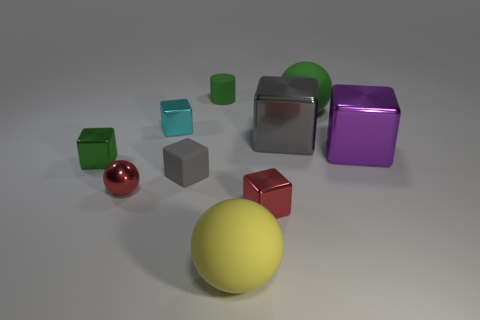What material is the object that is the same color as the shiny sphere?
Offer a terse response. Metal. There is a gray object that is the same material as the big purple block; what shape is it?
Your answer should be compact. Cube. There is a green cube; what number of red cubes are behind it?
Give a very brief answer. 0. There is a small thing that is in front of the small gray rubber cube and to the left of the cylinder; what is its material?
Your answer should be very brief. Metal. How many objects are the same size as the green ball?
Keep it short and to the point. 3. What is the color of the small matte object behind the small gray cube behind the red ball?
Offer a very short reply. Green. Are any small things visible?
Keep it short and to the point. Yes. Does the cyan shiny object have the same shape as the small green matte thing?
Provide a short and direct response. No. There is a object that is the same color as the small ball; what size is it?
Offer a terse response. Small. How many cylinders are behind the big rubber thing that is behind the small green metal cube?
Give a very brief answer. 1. 